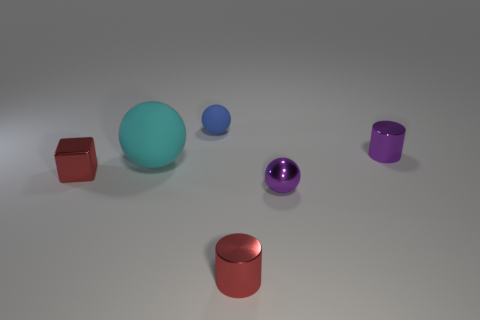Subtract all rubber spheres. How many spheres are left? 1 Subtract all cubes. How many objects are left? 5 Subtract 1 cylinders. How many cylinders are left? 1 Subtract all yellow balls. How many yellow cylinders are left? 0 Subtract all small blue matte balls. Subtract all gray shiny balls. How many objects are left? 5 Add 1 shiny blocks. How many shiny blocks are left? 2 Add 5 brown rubber objects. How many brown rubber objects exist? 5 Add 1 tiny blue matte balls. How many objects exist? 7 Subtract all blue spheres. How many spheres are left? 2 Subtract 0 red balls. How many objects are left? 6 